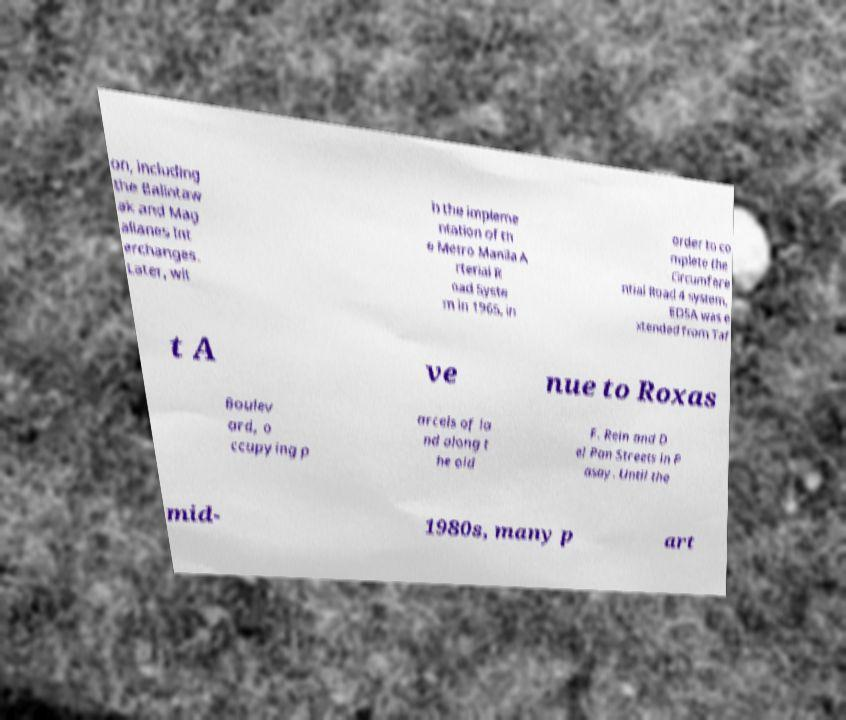Could you assist in decoding the text presented in this image and type it out clearly? on, including the Balintaw ak and Mag allanes Int erchanges. Later, wit h the impleme ntation of th e Metro Manila A rterial R oad Syste m in 1965, in order to co mplete the Circumfere ntial Road 4 system, EDSA was e xtended from Taf t A ve nue to Roxas Boulev ard, o ccupying p arcels of la nd along t he old F. Rein and D el Pan Streets in P asay. Until the mid- 1980s, many p art 